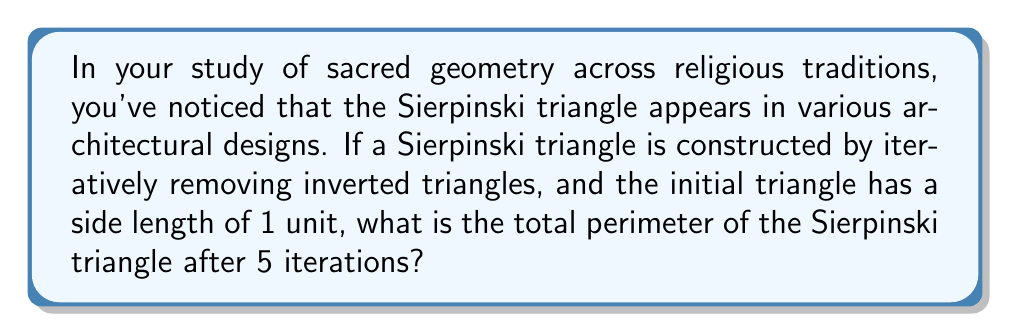What is the answer to this math problem? Let's approach this step-by-step:

1) First, we need to understand how the Sierpinski triangle evolves:
   - At iteration 0, we have a single triangle with side length 1.
   - At each subsequent iteration, we remove the middle inverted triangle from each remaining triangle.

2) Let's calculate the number of line segments and their lengths at each iteration:
   - Iteration 0: 3 segments of length 1
   - Iteration 1: 3 segments of length 1, plus 3 segments of length 1/2
   - Iteration 2: 3 segments of length 1, plus 3 segments of length 1/2, plus 9 segments of length 1/4
   - And so on...

3) We can express this as a series:
   $$P_n = 3 \cdot (1 + \frac{1}{2} + \frac{1}{4} + ... + \frac{1}{2^{n-1}})$$
   where $P_n$ is the perimeter after n iterations.

4) This is a geometric series with first term $a=1$ and common ratio $r=\frac{1}{2}$. The sum of such a series up to n terms is given by:
   $$S_n = a \cdot \frac{1-r^n}{1-r}$$

5) Substituting our values:
   $$P_5 = 3 \cdot (1 \cdot \frac{1-(\frac{1}{2})^5}{1-\frac{1}{2}})$$

6) Simplifying:
   $$P_5 = 3 \cdot (2 \cdot (1-\frac{1}{32})) = 3 \cdot (2 \cdot \frac{31}{32}) = 3 \cdot \frac{31}{16} = \frac{93}{16}$$

Therefore, after 5 iterations, the total perimeter of the Sierpinski triangle is $\frac{93}{16}$ units.
Answer: $\frac{93}{16}$ units 